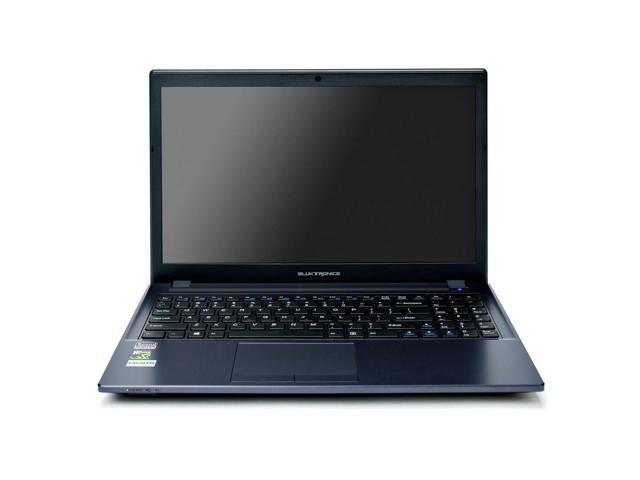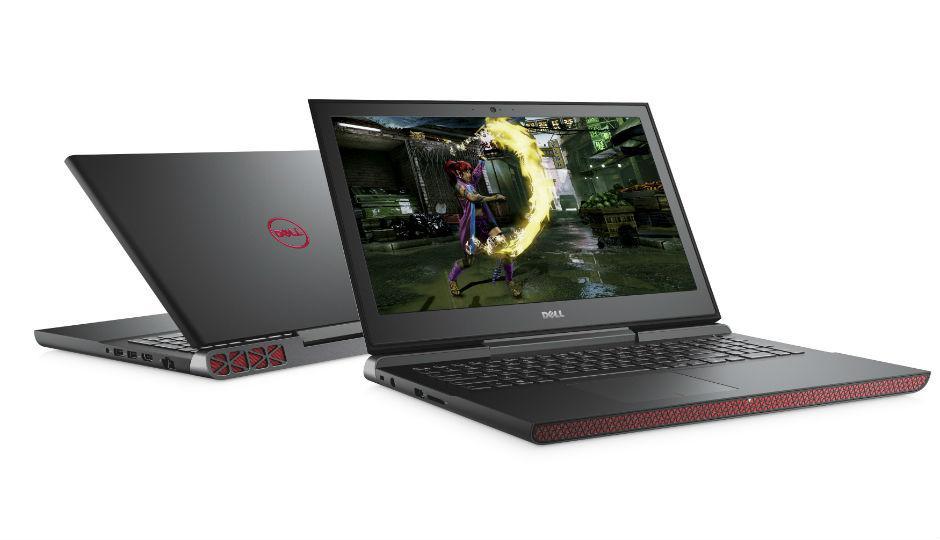The first image is the image on the left, the second image is the image on the right. Examine the images to the left and right. Is the description "The left and right image contains the same number of laptops with one half opened and the other fully opened." accurate? Answer yes or no. No. The first image is the image on the left, the second image is the image on the right. Given the left and right images, does the statement "Each image contains a single laptop, and one image features a laptop with the screen open to at least a right angle and visible, and the other image shows a laptop facing backward and open at less than 90-degrees." hold true? Answer yes or no. No. 